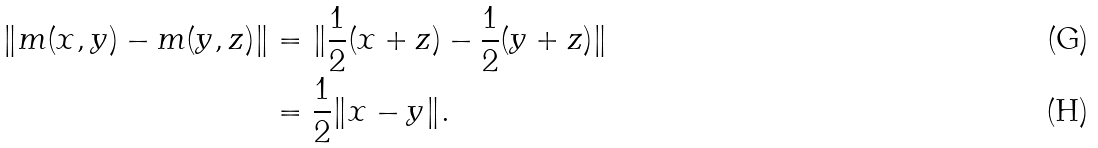Convert formula to latex. <formula><loc_0><loc_0><loc_500><loc_500>\| m ( x , y ) - m ( y , z ) \| & = \| \frac { 1 } { 2 } ( x + z ) - \frac { 1 } { 2 } ( y + z ) \| \\ & = \frac { 1 } { 2 } \| x - y \| .</formula> 